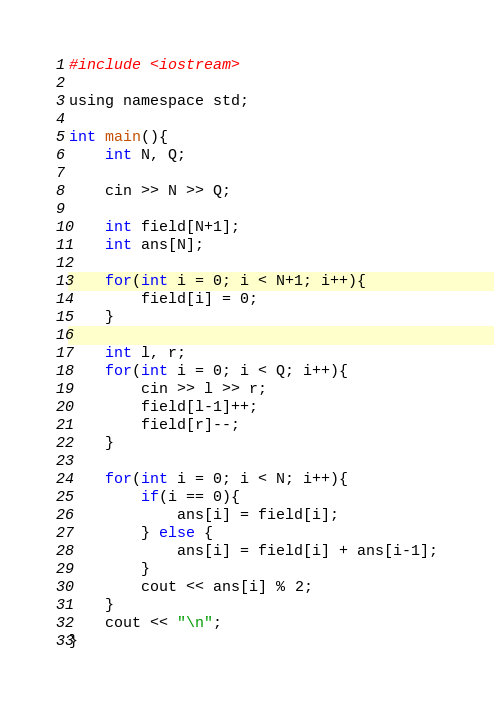<code> <loc_0><loc_0><loc_500><loc_500><_C_>#include <iostream>

using namespace std;

int main(){
	int N, Q;

	cin >> N >> Q;

	int field[N+1];
	int ans[N];

	for(int i = 0; i < N+1; i++){
		field[i] = 0;
	}

	int l, r;
	for(int i = 0; i < Q; i++){
		cin >> l >> r;
		field[l-1]++;
		field[r]--;
	}

	for(int i = 0; i < N; i++){
		if(i == 0){
			ans[i] = field[i];
		} else {
			ans[i] = field[i] + ans[i-1];
		}
		cout << ans[i] % 2;
	}
	cout << "\n";
}</code> 